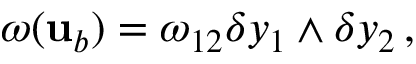<formula> <loc_0><loc_0><loc_500><loc_500>\omega ( { u } _ { b } ) = \omega _ { 1 2 } \delta y _ { 1 } \wedge \delta y _ { 2 } \, ,</formula> 